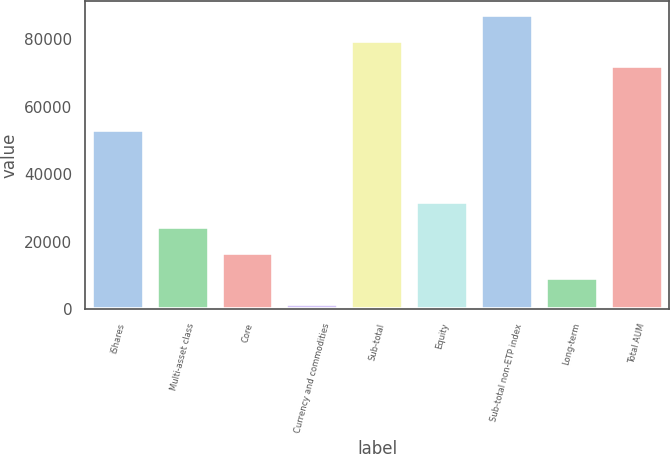Convert chart. <chart><loc_0><loc_0><loc_500><loc_500><bar_chart><fcel>iShares<fcel>Multi-asset class<fcel>Core<fcel>Currency and commodities<fcel>Sub-total<fcel>Equity<fcel>Sub-total non-ETP index<fcel>Long-term<fcel>Total AUM<nl><fcel>52973<fcel>24288.5<fcel>16708<fcel>1547<fcel>79537.5<fcel>31869<fcel>87118<fcel>9127.5<fcel>71957<nl></chart> 